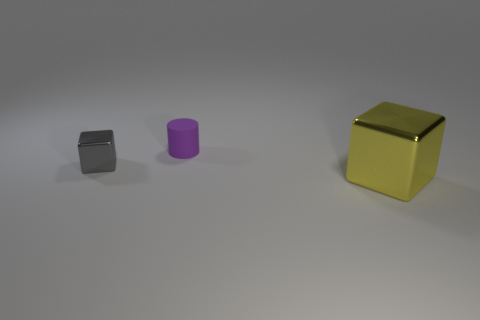Add 1 big blocks. How many objects exist? 4 Subtract all blocks. How many objects are left? 1 Subtract 0 blue spheres. How many objects are left? 3 Subtract all purple matte cylinders. Subtract all big blocks. How many objects are left? 1 Add 1 matte things. How many matte things are left? 2 Add 3 small rubber objects. How many small rubber objects exist? 4 